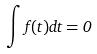Convert formula to latex. <formula><loc_0><loc_0><loc_500><loc_500>\int f ( t ) d t = 0</formula> 